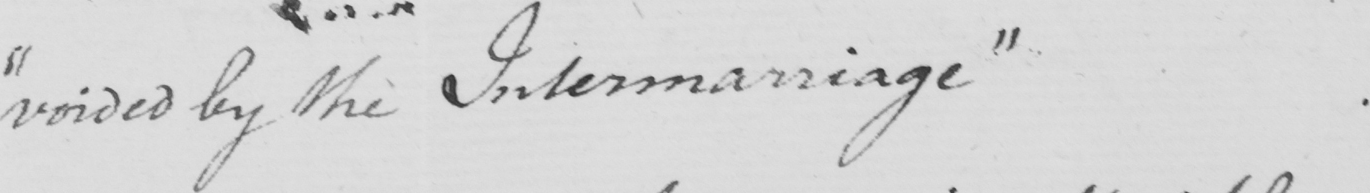What does this handwritten line say? " voided by the Intermarriage " 